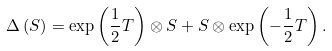Convert formula to latex. <formula><loc_0><loc_0><loc_500><loc_500>\Delta \left ( S \right ) = \exp \left ( \frac { 1 } { 2 } T \right ) \otimes S + S \otimes \exp \left ( - \frac { 1 } { 2 } T \right ) .</formula> 